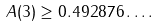Convert formula to latex. <formula><loc_0><loc_0><loc_500><loc_500>A ( 3 ) \geq 0 . 4 9 2 8 7 6 \dots .</formula> 